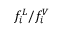<formula> <loc_0><loc_0><loc_500><loc_500>f _ { i } ^ { L } / f _ { i } ^ { V }</formula> 